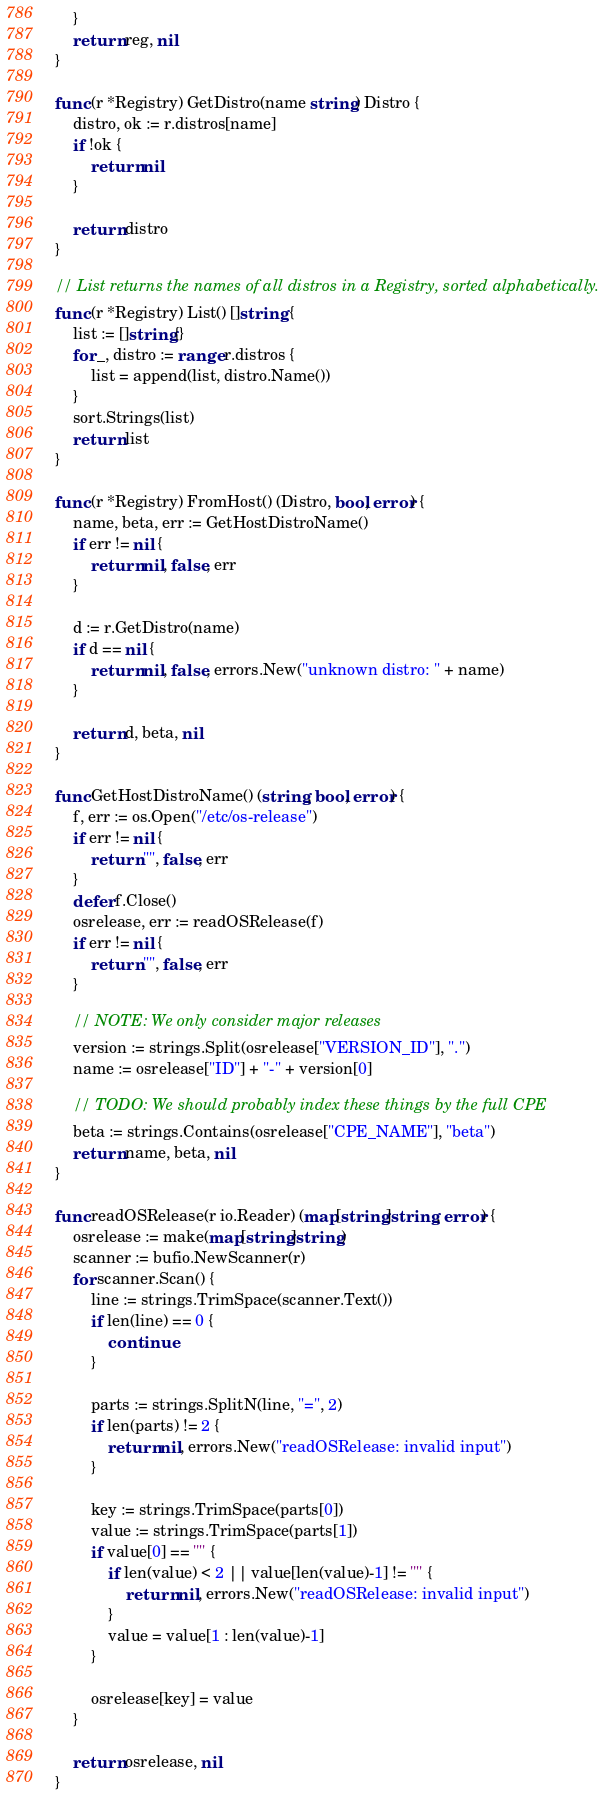<code> <loc_0><loc_0><loc_500><loc_500><_Go_>	}
	return reg, nil
}

func (r *Registry) GetDistro(name string) Distro {
	distro, ok := r.distros[name]
	if !ok {
		return nil
	}

	return distro
}

// List returns the names of all distros in a Registry, sorted alphabetically.
func (r *Registry) List() []string {
	list := []string{}
	for _, distro := range r.distros {
		list = append(list, distro.Name())
	}
	sort.Strings(list)
	return list
}

func (r *Registry) FromHost() (Distro, bool, error) {
	name, beta, err := GetHostDistroName()
	if err != nil {
		return nil, false, err
	}

	d := r.GetDistro(name)
	if d == nil {
		return nil, false, errors.New("unknown distro: " + name)
	}

	return d, beta, nil
}

func GetHostDistroName() (string, bool, error) {
	f, err := os.Open("/etc/os-release")
	if err != nil {
		return "", false, err
	}
	defer f.Close()
	osrelease, err := readOSRelease(f)
	if err != nil {
		return "", false, err
	}

	// NOTE: We only consider major releases
	version := strings.Split(osrelease["VERSION_ID"], ".")
	name := osrelease["ID"] + "-" + version[0]

	// TODO: We should probably index these things by the full CPE
	beta := strings.Contains(osrelease["CPE_NAME"], "beta")
	return name, beta, nil
}

func readOSRelease(r io.Reader) (map[string]string, error) {
	osrelease := make(map[string]string)
	scanner := bufio.NewScanner(r)
	for scanner.Scan() {
		line := strings.TrimSpace(scanner.Text())
		if len(line) == 0 {
			continue
		}

		parts := strings.SplitN(line, "=", 2)
		if len(parts) != 2 {
			return nil, errors.New("readOSRelease: invalid input")
		}

		key := strings.TrimSpace(parts[0])
		value := strings.TrimSpace(parts[1])
		if value[0] == '"' {
			if len(value) < 2 || value[len(value)-1] != '"' {
				return nil, errors.New("readOSRelease: invalid input")
			}
			value = value[1 : len(value)-1]
		}

		osrelease[key] = value
	}

	return osrelease, nil
}
</code> 